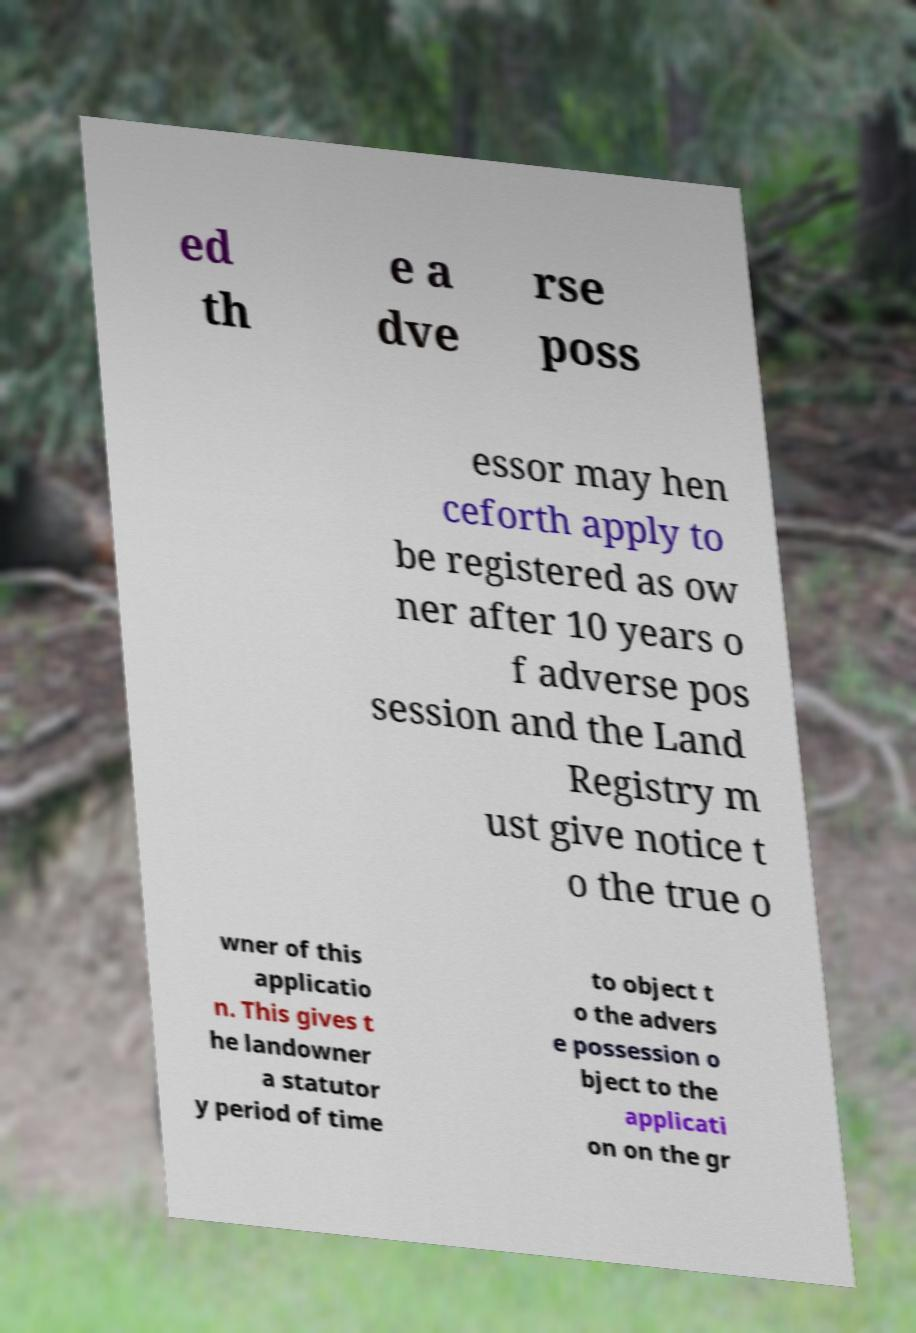Please identify and transcribe the text found in this image. ed th e a dve rse poss essor may hen ceforth apply to be registered as ow ner after 10 years o f adverse pos session and the Land Registry m ust give notice t o the true o wner of this applicatio n. This gives t he landowner a statutor y period of time to object t o the advers e possession o bject to the applicati on on the gr 